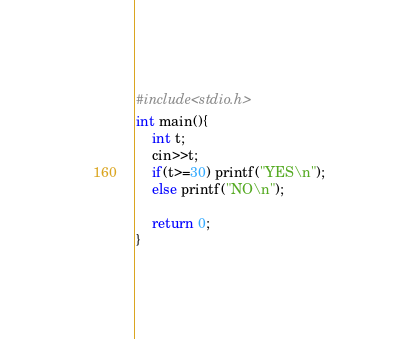<code> <loc_0><loc_0><loc_500><loc_500><_C_>#include<stdio.h>
int main(){
	int t;	
  	cin>>t;
	if(t>=30) printf("YES\n");
  	else printf("NO\n");
  	
  	return 0;
}
</code> 